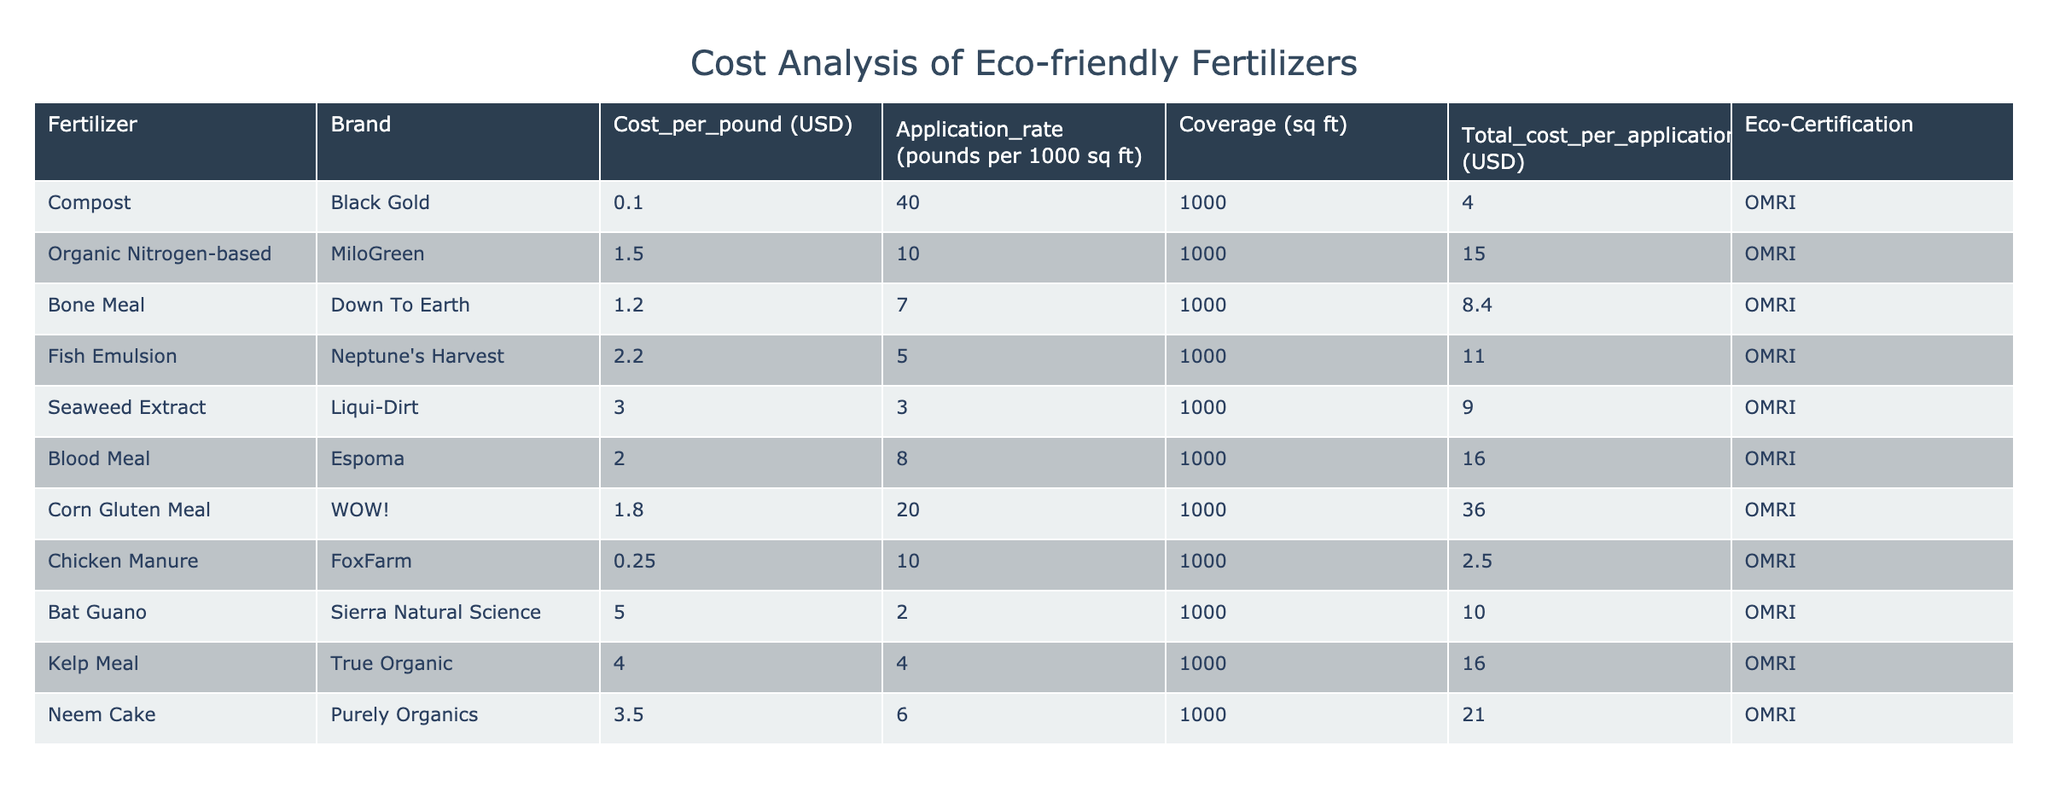What is the cost per application of Bone Meal? The table shows the Total_cost_per_application for Bone Meal under the Brand Down To Earth. It indicates that the cost for this fertilizer is 8.40 USD per application.
Answer: 8.40 USD Which fertilizer has the highest cost per pound? By scanning through the Cost_per_pound column, we can see that Bat Guano, from the brand Sierra Natural Science, has the highest cost at 5.00 USD per pound.
Answer: 5.00 USD What is the total cost of using Corn Gluten Meal for an area of 3000 sq ft? First, we find the Total_cost_per_application for Corn Gluten Meal, which is 36.00 USD for 1000 sq ft. Therefore, to calculate for 3000 sq ft, we multiply by 3: 36.00 USD * 3 = 108.00 USD.
Answer: 108.00 USD Does Fish Emulsion have an Eco-Certification? Looking at the Eco-Certification column for Fish Emulsion, it lists "OMRI," indicating that it is indeed eco-certified.
Answer: Yes If we combine the total costs of each application for Organic Nitrogen-based fertilizer and Blood Meal, what would that be? The Total_cost_per_application for Organic Nitrogen-based fertilizer is 15.00 USD and for Blood Meal, it is 16.00 USD. Adding those together gives us 15.00 USD + 16.00 USD = 31.00 USD.
Answer: 31.00 USD Which fertilizer provides the best coverage per dollar spent? To determine this, we need to calculate coverage per dollar for each fertilizer. For instance, Compost (1000 sq ft / 4.00 USD) gives 250 sq ft/USD, while Chicken Manure (1000 sq ft / 2.50 USD) gives 400 sq ft/USD. Comparatively, Chicken Manure provides the best coverage per dollar spent at 400 sq ft/USD.
Answer: Chicken Manure What is the average cost per application for all the fertilizers listed? First, we sum up all the Total_cost_per_application values: 4.00 + 15.00 + 8.40 + 11.00 + 9.00 + 16.00 + 36.00 + 2.50 + 10.00 + 16.00 + 21.00 =  148.90 USD. There are 11 fertilizers, thus the average is 148.90 USD / 11 ≈ 13.54 USD.
Answer: 13.54 USD Is the cost per pound of Chicken Manure less than that of Bone Meal? Chicken Manure costs 0.25 USD per pound while Bone Meal costs 1.20 USD per pound. Since 0.25 USD is less than 1.20 USD, the statement is true.
Answer: Yes 